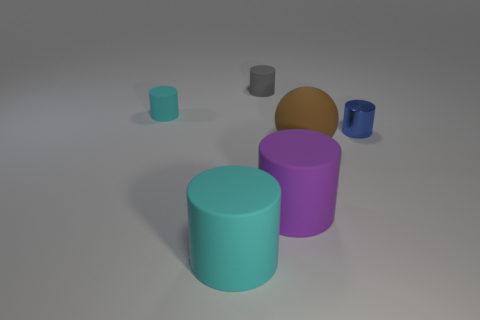Is the number of gray rubber things less than the number of cyan things?
Your answer should be compact. Yes. How many cylinders are either blue objects or tiny matte objects?
Give a very brief answer. 3. What number of big cylinders are the same color as the tiny shiny cylinder?
Keep it short and to the point. 0. There is a object that is both right of the tiny gray cylinder and in front of the brown rubber sphere; what size is it?
Give a very brief answer. Large. Are there fewer cyan rubber cylinders behind the small blue shiny object than brown shiny things?
Your answer should be compact. No. Is the large sphere made of the same material as the large cyan thing?
Ensure brevity in your answer.  Yes. What number of objects are purple matte cylinders or large matte things?
Your answer should be very brief. 3. What number of small cylinders are the same material as the large purple cylinder?
Offer a very short reply. 2. The gray matte object that is the same shape as the purple rubber object is what size?
Provide a short and direct response. Small. There is a big cyan matte thing; are there any tiny rubber objects in front of it?
Provide a succinct answer. No. 